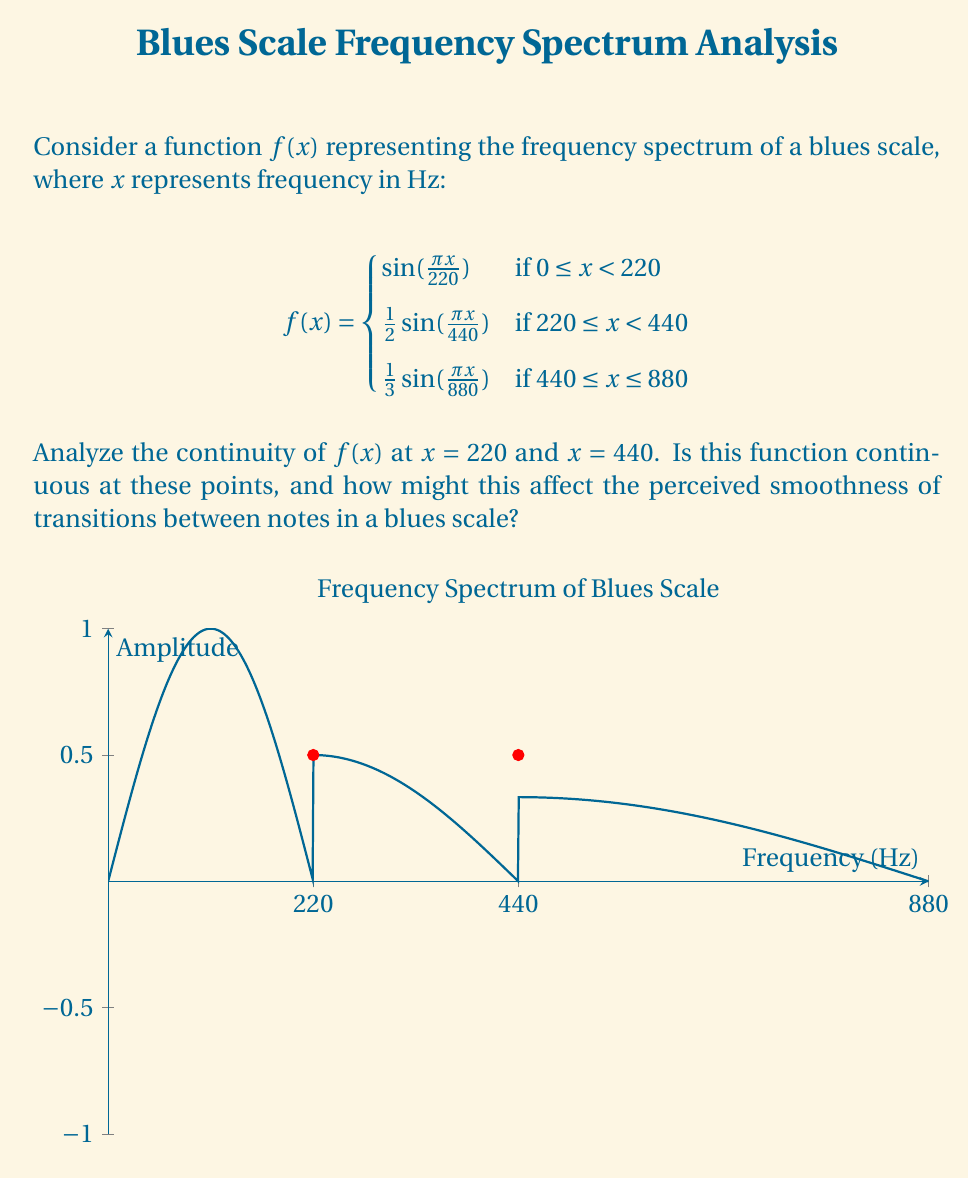Could you help me with this problem? To analyze the continuity of $f(x)$ at $x = 220$ and $x = 440$, we need to check if the function is continuous from both left and right sides at these points.

1. At $x = 220$:
   Left limit: $\lim_{x \to 220^-} f(x) = \sin(\frac{\pi \cdot 220}{220}) = \sin(\pi) = 0$
   Right limit: $\lim_{x \to 220^+} f(x) = \frac{1}{2}\sin(\frac{\pi \cdot 220}{440}) = \frac{1}{2}\sin(\frac{\pi}{2}) = \frac{1}{2}$
   $f(220) = \frac{1}{2}\sin(\frac{\pi \cdot 220}{440}) = \frac{1}{2}$

   Since the left limit doesn't equal the right limit, $f(x)$ is discontinuous at $x = 220$.

2. At $x = 440$:
   Left limit: $\lim_{x \to 440^-} f(x) = \frac{1}{2}\sin(\frac{\pi \cdot 440}{440}) = \frac{1}{2}\sin(\pi) = 0$
   Right limit: $\lim_{x \to 440^+} f(x) = \frac{1}{3}\sin(\frac{\pi \cdot 440}{880}) = \frac{1}{3}\sin(\frac{\pi}{2}) = \frac{1}{3}$
   $f(440) = \frac{1}{2}\sin(\frac{\pi \cdot 440}{440}) = 0$

   The left limit equals $f(440)$, but the right limit doesn't. Therefore, $f(x)$ is also discontinuous at $x = 440$.

The discontinuities at these frequencies (220 Hz and 440 Hz) represent abrupt changes in the amplitude of the harmonics in the blues scale. In terms of music perception, these discontinuities might manifest as sudden changes in timbre or volume when transitioning between notes, potentially affecting the smoothness of the overall sound. A skilled blues guitarist might exploit these characteristics to create distinctive "breaks" or emphases in their playing, contributing to the unique sound of blues music.
Answer: $f(x)$ is discontinuous at both $x = 220$ and $x = 440$. 